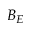<formula> <loc_0><loc_0><loc_500><loc_500>B _ { E }</formula> 